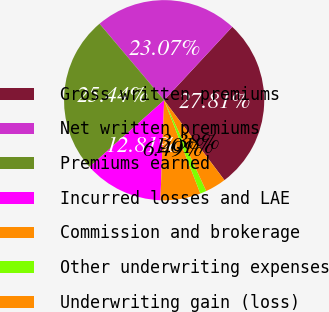Convert chart to OTSL. <chart><loc_0><loc_0><loc_500><loc_500><pie_chart><fcel>Gross written premiums<fcel>Net written premiums<fcel>Premiums earned<fcel>Incurred losses and LAE<fcel>Commission and brokerage<fcel>Other underwriting expenses<fcel>Underwriting gain (loss)<nl><fcel>27.81%<fcel>23.07%<fcel>25.44%<fcel>12.81%<fcel>6.49%<fcel>1.01%<fcel>3.38%<nl></chart> 